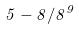<formula> <loc_0><loc_0><loc_500><loc_500>5 - 8 / 8 ^ { 9 }</formula> 